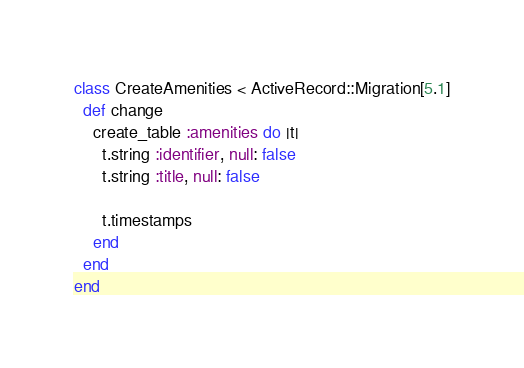<code> <loc_0><loc_0><loc_500><loc_500><_Ruby_>class CreateAmenities < ActiveRecord::Migration[5.1]
  def change
    create_table :amenities do |t|
      t.string :identifier, null: false
      t.string :title, null: false
      
      t.timestamps
    end
  end
end
</code> 